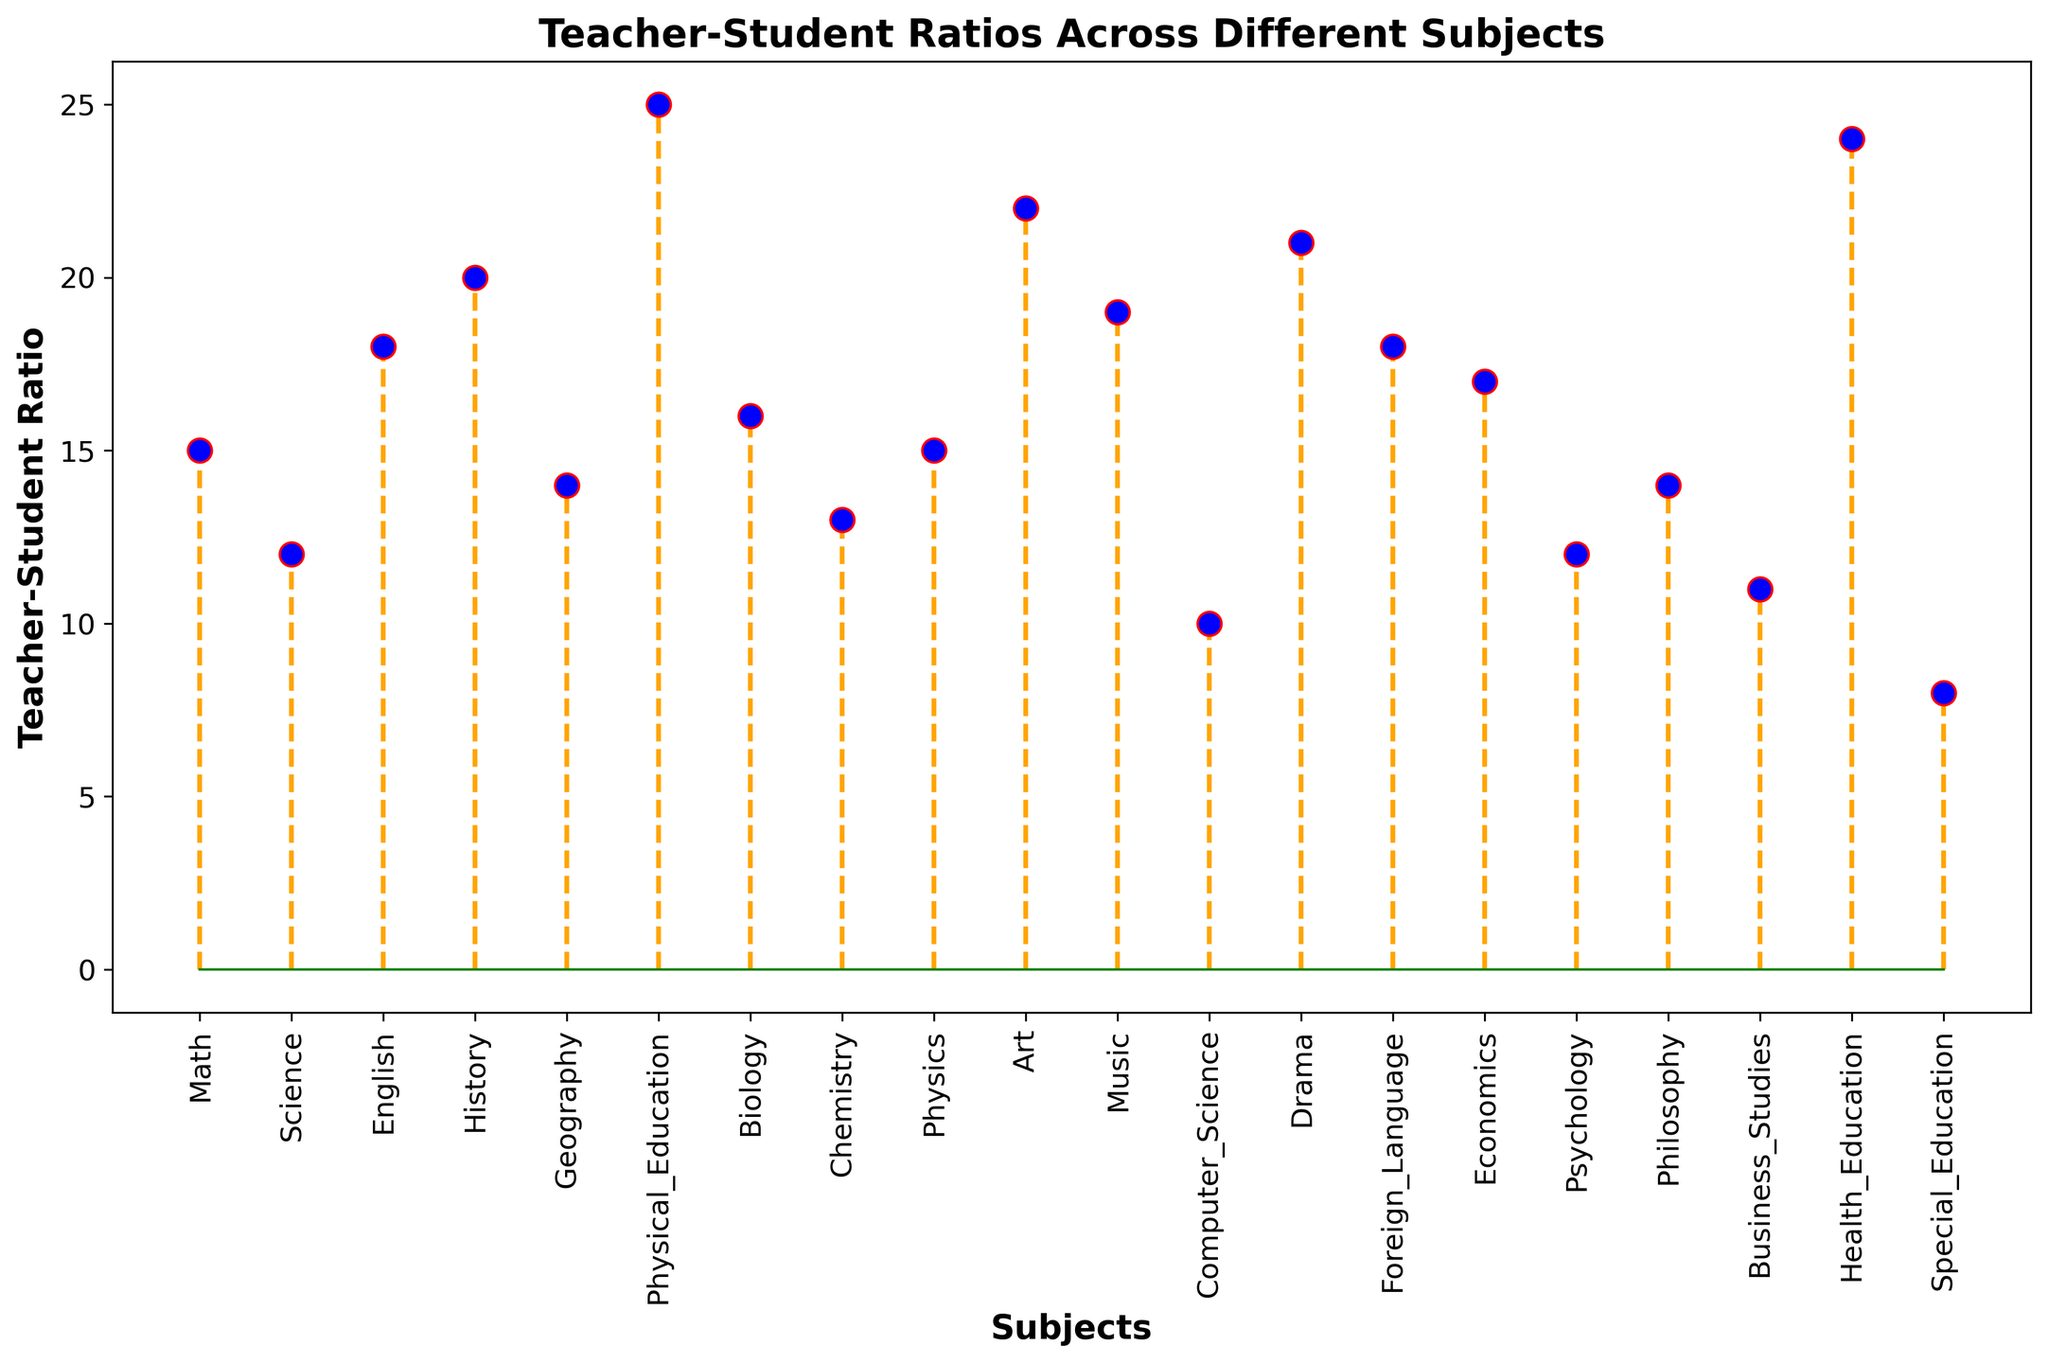What's the highest teacher-student ratio in the figure? To determine the highest teacher-student ratio, we examine the highest point on the plot. The tallest stem, corresponding to Physical Education, has a teacher-student ratio of 25.
Answer: 25 Which subjects have the same teacher-student ratio of 18? To identify subjects with the same ratio of 18, we look at the stems that reach the level of 18 on the y-axis. The subjects corresponding to this level are English and Foreign Language.
Answer: English and Foreign Language What's the difference between the highest and lowest teacher-student ratios? To find the difference, we subtract the smallest value from the largest one. The highest ratio is 25 (Physical Education) and the lowest is 8 (Special Education). The difference is 25 - 8 = 17.
Answer: 17 How many subjects have a teacher-student ratio greater than 20? To count the subjects with a ratio greater than 20, we scan the plot for stems exceeding the 20 mark on the y-axis. The subjects are Physical Education, Art, Drama, and Health Education, totaling 4 subjects.
Answer: 4 Which subject has a teacher-student ratio closest to the median of all subjects? To find the median, we list the ratios in ascending order: 8, 10, 11, 12, 12, 13, 14, 14, 15, 15, 16, 17, 18, 18, 19, 20, 21, 22, 24, 25. The median is the average of the 10th and 11th values: (15+16)/2 = 15.5. The closest subject to 15.5 is Physics and Math, both having a ratio of 15.
Answer: Physics and Math What's the average teacher-student ratio across all subjects? The average ratio is obtained by summing all ratios and dividing by the number of subjects. The sum is 314 and the number of subjects is 20. The average is 314 / 20 = 15.7.
Answer: 15.7 Which subject has the teacher-student ratio closest to the average? The average teacher-student ratio is 15.7. The closest ratios to this value are Math and Physics both at 15.
Answer: Math and Physics Is the teacher-student ratio for Chemistry higher or lower compared to History? By comparing the heights of the stems for both Chemistry and History, Chemistry has a ratio of 13, while History has a higher ratio of 20.
Answer: Lower What are the teacher-student ratios for subjects that involve physical activity? From the plot, the subjects involving physical activity are Physical Education with a ratio of 25 and Health Education with a ratio of 24.
Answer: 25 and 24 